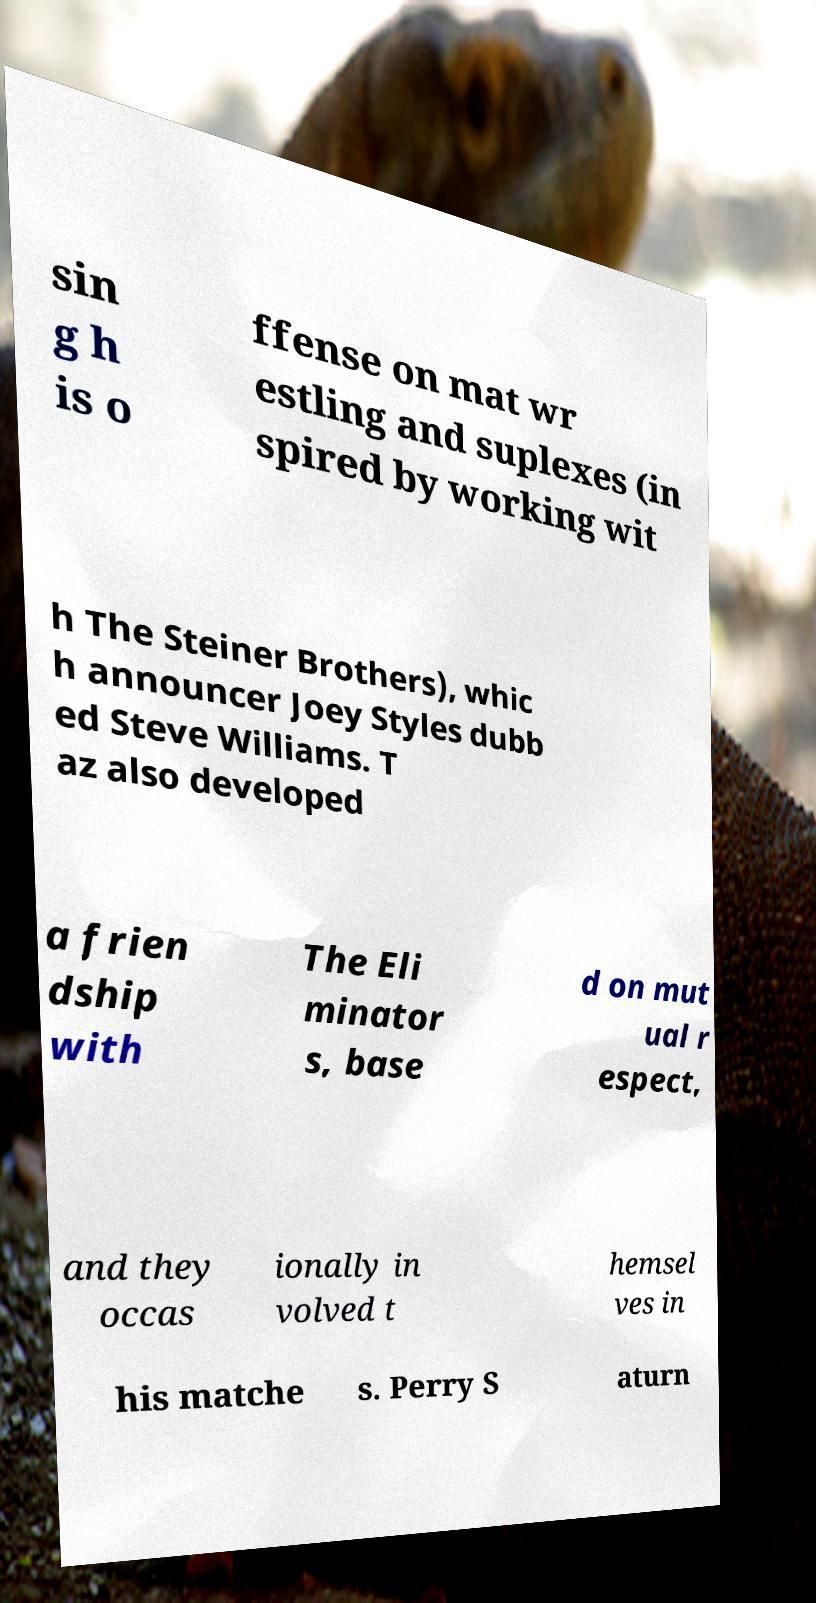Can you read and provide the text displayed in the image?This photo seems to have some interesting text. Can you extract and type it out for me? sin g h is o ffense on mat wr estling and suplexes (in spired by working wit h The Steiner Brothers), whic h announcer Joey Styles dubb ed Steve Williams. T az also developed a frien dship with The Eli minator s, base d on mut ual r espect, and they occas ionally in volved t hemsel ves in his matche s. Perry S aturn 